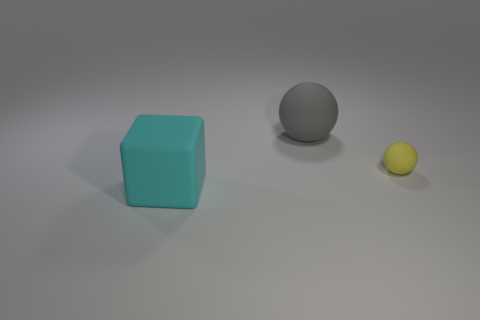What is the size of the cyan thing that is made of the same material as the small ball?
Offer a terse response. Large. Are there any large gray balls right of the yellow rubber thing?
Make the answer very short. No. Does the big cyan object have the same shape as the large gray rubber object?
Offer a terse response. No. There is a object behind the rubber ball that is in front of the big matte object right of the big cyan thing; what is its size?
Give a very brief answer. Large. Is the shape of the yellow rubber object the same as the thing that is behind the tiny rubber sphere?
Ensure brevity in your answer.  Yes. What number of big brown spheres are there?
Ensure brevity in your answer.  0. What number of purple things are either rubber things or cubes?
Keep it short and to the point. 0. What number of other things are the same shape as the cyan thing?
Your answer should be compact. 0. How many tiny objects are cyan rubber cubes or blue rubber things?
Your answer should be compact. 0. There is another object that is the same shape as the small thing; what size is it?
Ensure brevity in your answer.  Large. 